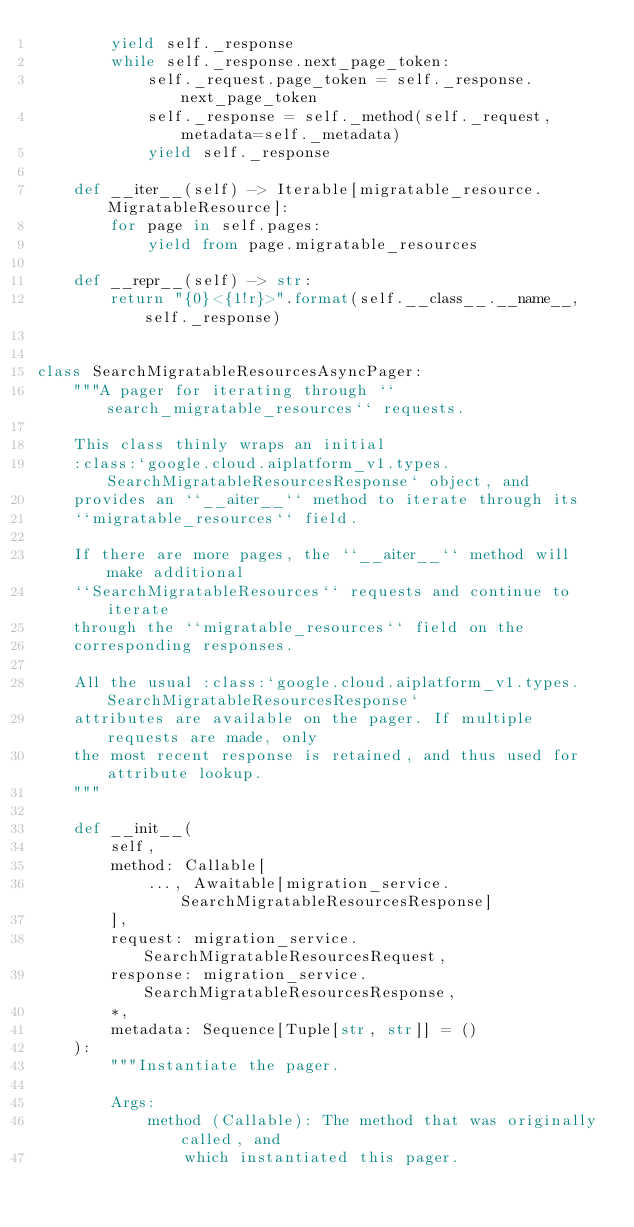Convert code to text. <code><loc_0><loc_0><loc_500><loc_500><_Python_>        yield self._response
        while self._response.next_page_token:
            self._request.page_token = self._response.next_page_token
            self._response = self._method(self._request, metadata=self._metadata)
            yield self._response

    def __iter__(self) -> Iterable[migratable_resource.MigratableResource]:
        for page in self.pages:
            yield from page.migratable_resources

    def __repr__(self) -> str:
        return "{0}<{1!r}>".format(self.__class__.__name__, self._response)


class SearchMigratableResourcesAsyncPager:
    """A pager for iterating through ``search_migratable_resources`` requests.

    This class thinly wraps an initial
    :class:`google.cloud.aiplatform_v1.types.SearchMigratableResourcesResponse` object, and
    provides an ``__aiter__`` method to iterate through its
    ``migratable_resources`` field.

    If there are more pages, the ``__aiter__`` method will make additional
    ``SearchMigratableResources`` requests and continue to iterate
    through the ``migratable_resources`` field on the
    corresponding responses.

    All the usual :class:`google.cloud.aiplatform_v1.types.SearchMigratableResourcesResponse`
    attributes are available on the pager. If multiple requests are made, only
    the most recent response is retained, and thus used for attribute lookup.
    """

    def __init__(
        self,
        method: Callable[
            ..., Awaitable[migration_service.SearchMigratableResourcesResponse]
        ],
        request: migration_service.SearchMigratableResourcesRequest,
        response: migration_service.SearchMigratableResourcesResponse,
        *,
        metadata: Sequence[Tuple[str, str]] = ()
    ):
        """Instantiate the pager.

        Args:
            method (Callable): The method that was originally called, and
                which instantiated this pager.</code> 